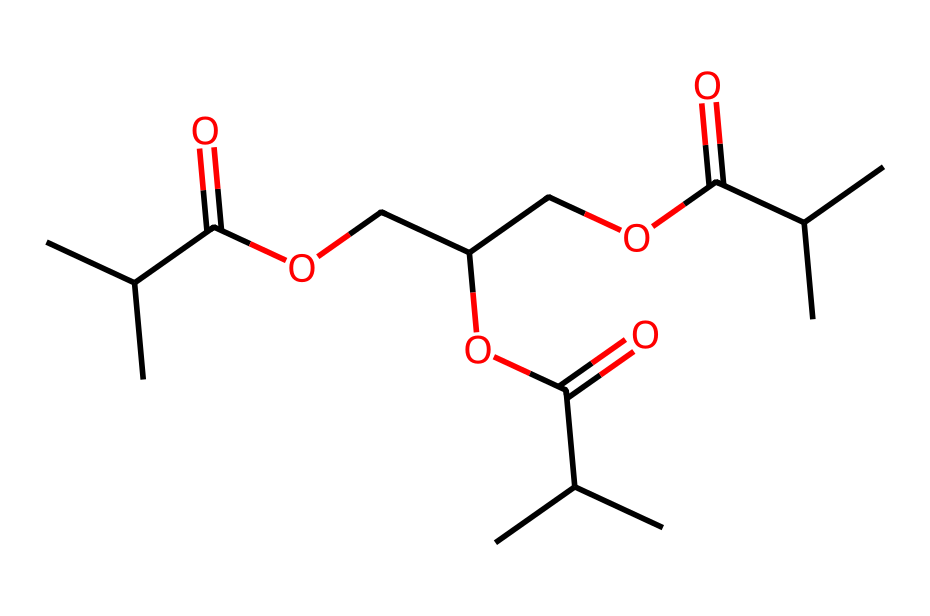how many carbon atoms are present in this molecule? By analyzing the provided SMILES representation, we can count the number of "C" symbols, which represent carbon atoms. Upon counting, there are 18 carbon atoms in the structure.
Answer: 18 what type of functional group is present in this biodegradable plastic? The molecule contains the carboxylic acid functional group, which can be identified by the presence of “C(=O)O” in the SMILES. This indicates that there are ester linkages and other functional groups derived from acids.
Answer: carboxylic acid is this plastic likely to be more environmentally friendly than traditional plastics? The presence of ester bonds and the structural features suggest that this plastic is biodegradable, indicating that it is designed to break down more easily in the environment compared to traditional plastics.
Answer: yes how many ester linkages are present in this plastic structure? By examining the SMILES representation and noting the repeating patterns of “COC(=O)”, we can identify the ester linkages within the molecule. In this case, there are 3 ester linkages.
Answer: 3 does this molecule contain any cyclic structures? By analyzing the provided SMILES, it can be noted that there are no rings or cyclic structures present, as there are no indications of enclosed paths in the notation.
Answer: no what is the molecular formula derived from this structure? To derive the molecular formula, we compile the elements and their quantities based on the counted atoms in the SMILES. We find there are 18 carbon atoms, 34 hydrogen atoms, and 6 oxygen atoms. Thus, the molecular formula is C18H34O6.
Answer: C18H34O6 